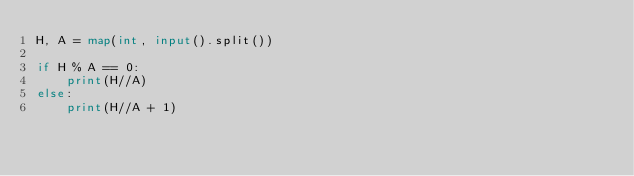Convert code to text. <code><loc_0><loc_0><loc_500><loc_500><_Python_>H, A = map(int, input().split())

if H % A == 0:
    print(H//A)
else:
    print(H//A + 1)
</code> 